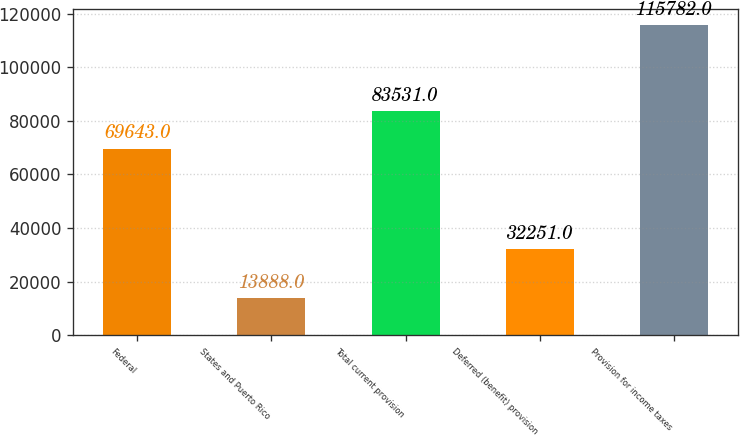<chart> <loc_0><loc_0><loc_500><loc_500><bar_chart><fcel>Federal<fcel>States and Puerto Rico<fcel>Total current provision<fcel>Deferred (benefit) provision<fcel>Provision for income taxes<nl><fcel>69643<fcel>13888<fcel>83531<fcel>32251<fcel>115782<nl></chart> 